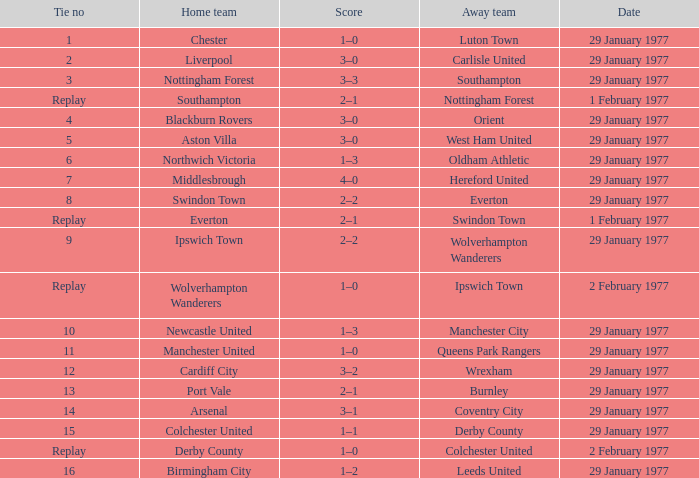What is the count in the liverpool home game? 3–0. Can you parse all the data within this table? {'header': ['Tie no', 'Home team', 'Score', 'Away team', 'Date'], 'rows': [['1', 'Chester', '1–0', 'Luton Town', '29 January 1977'], ['2', 'Liverpool', '3–0', 'Carlisle United', '29 January 1977'], ['3', 'Nottingham Forest', '3–3', 'Southampton', '29 January 1977'], ['Replay', 'Southampton', '2–1', 'Nottingham Forest', '1 February 1977'], ['4', 'Blackburn Rovers', '3–0', 'Orient', '29 January 1977'], ['5', 'Aston Villa', '3–0', 'West Ham United', '29 January 1977'], ['6', 'Northwich Victoria', '1–3', 'Oldham Athletic', '29 January 1977'], ['7', 'Middlesbrough', '4–0', 'Hereford United', '29 January 1977'], ['8', 'Swindon Town', '2–2', 'Everton', '29 January 1977'], ['Replay', 'Everton', '2–1', 'Swindon Town', '1 February 1977'], ['9', 'Ipswich Town', '2–2', 'Wolverhampton Wanderers', '29 January 1977'], ['Replay', 'Wolverhampton Wanderers', '1–0', 'Ipswich Town', '2 February 1977'], ['10', 'Newcastle United', '1–3', 'Manchester City', '29 January 1977'], ['11', 'Manchester United', '1–0', 'Queens Park Rangers', '29 January 1977'], ['12', 'Cardiff City', '3–2', 'Wrexham', '29 January 1977'], ['13', 'Port Vale', '2–1', 'Burnley', '29 January 1977'], ['14', 'Arsenal', '3–1', 'Coventry City', '29 January 1977'], ['15', 'Colchester United', '1–1', 'Derby County', '29 January 1977'], ['Replay', 'Derby County', '1–0', 'Colchester United', '2 February 1977'], ['16', 'Birmingham City', '1–2', 'Leeds United', '29 January 1977']]} 